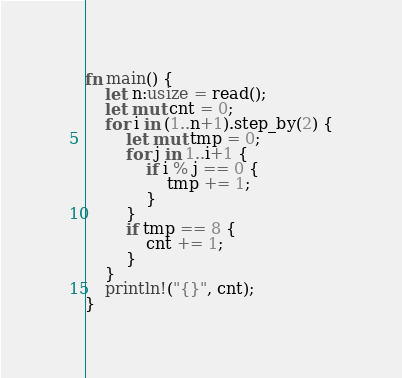<code> <loc_0><loc_0><loc_500><loc_500><_Rust_>fn main() {
    let n:usize = read();
    let mut cnt = 0;
    for i in (1..n+1).step_by(2) {
        let mut tmp = 0;
        for j in 1..i+1 {
            if i % j == 0 {
                tmp += 1;
            }
        }
        if tmp == 8 {
            cnt += 1;
        }
    }
    println!("{}", cnt);
}</code> 